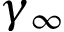<formula> <loc_0><loc_0><loc_500><loc_500>\gamma _ { \infty }</formula> 